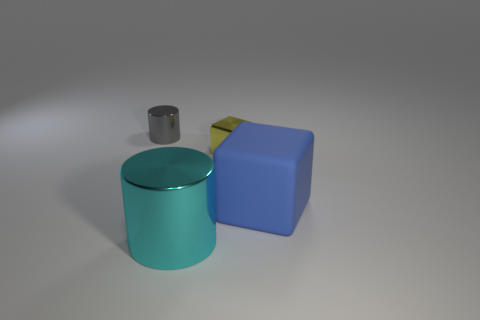Do the small gray metal object to the left of the large matte thing and the tiny thing on the right side of the large cyan object have the same shape?
Give a very brief answer. No. Is there any other thing that is the same material as the gray object?
Offer a very short reply. Yes. What material is the cyan thing?
Your answer should be very brief. Metal. There is a cylinder behind the large metal thing; what is it made of?
Give a very brief answer. Metal. Are there any other things that have the same color as the small metallic cylinder?
Keep it short and to the point. No. There is another cylinder that is the same material as the large cyan cylinder; what is its size?
Offer a very short reply. Small. What number of big things are blue rubber things or yellow metal cubes?
Give a very brief answer. 1. There is a thing that is behind the tiny object that is in front of the metal cylinder that is on the left side of the big cylinder; what is its size?
Provide a succinct answer. Small. What number of other cyan metallic cylinders are the same size as the cyan shiny cylinder?
Ensure brevity in your answer.  0. What number of things are either gray objects or big objects left of the rubber thing?
Offer a terse response. 2. 